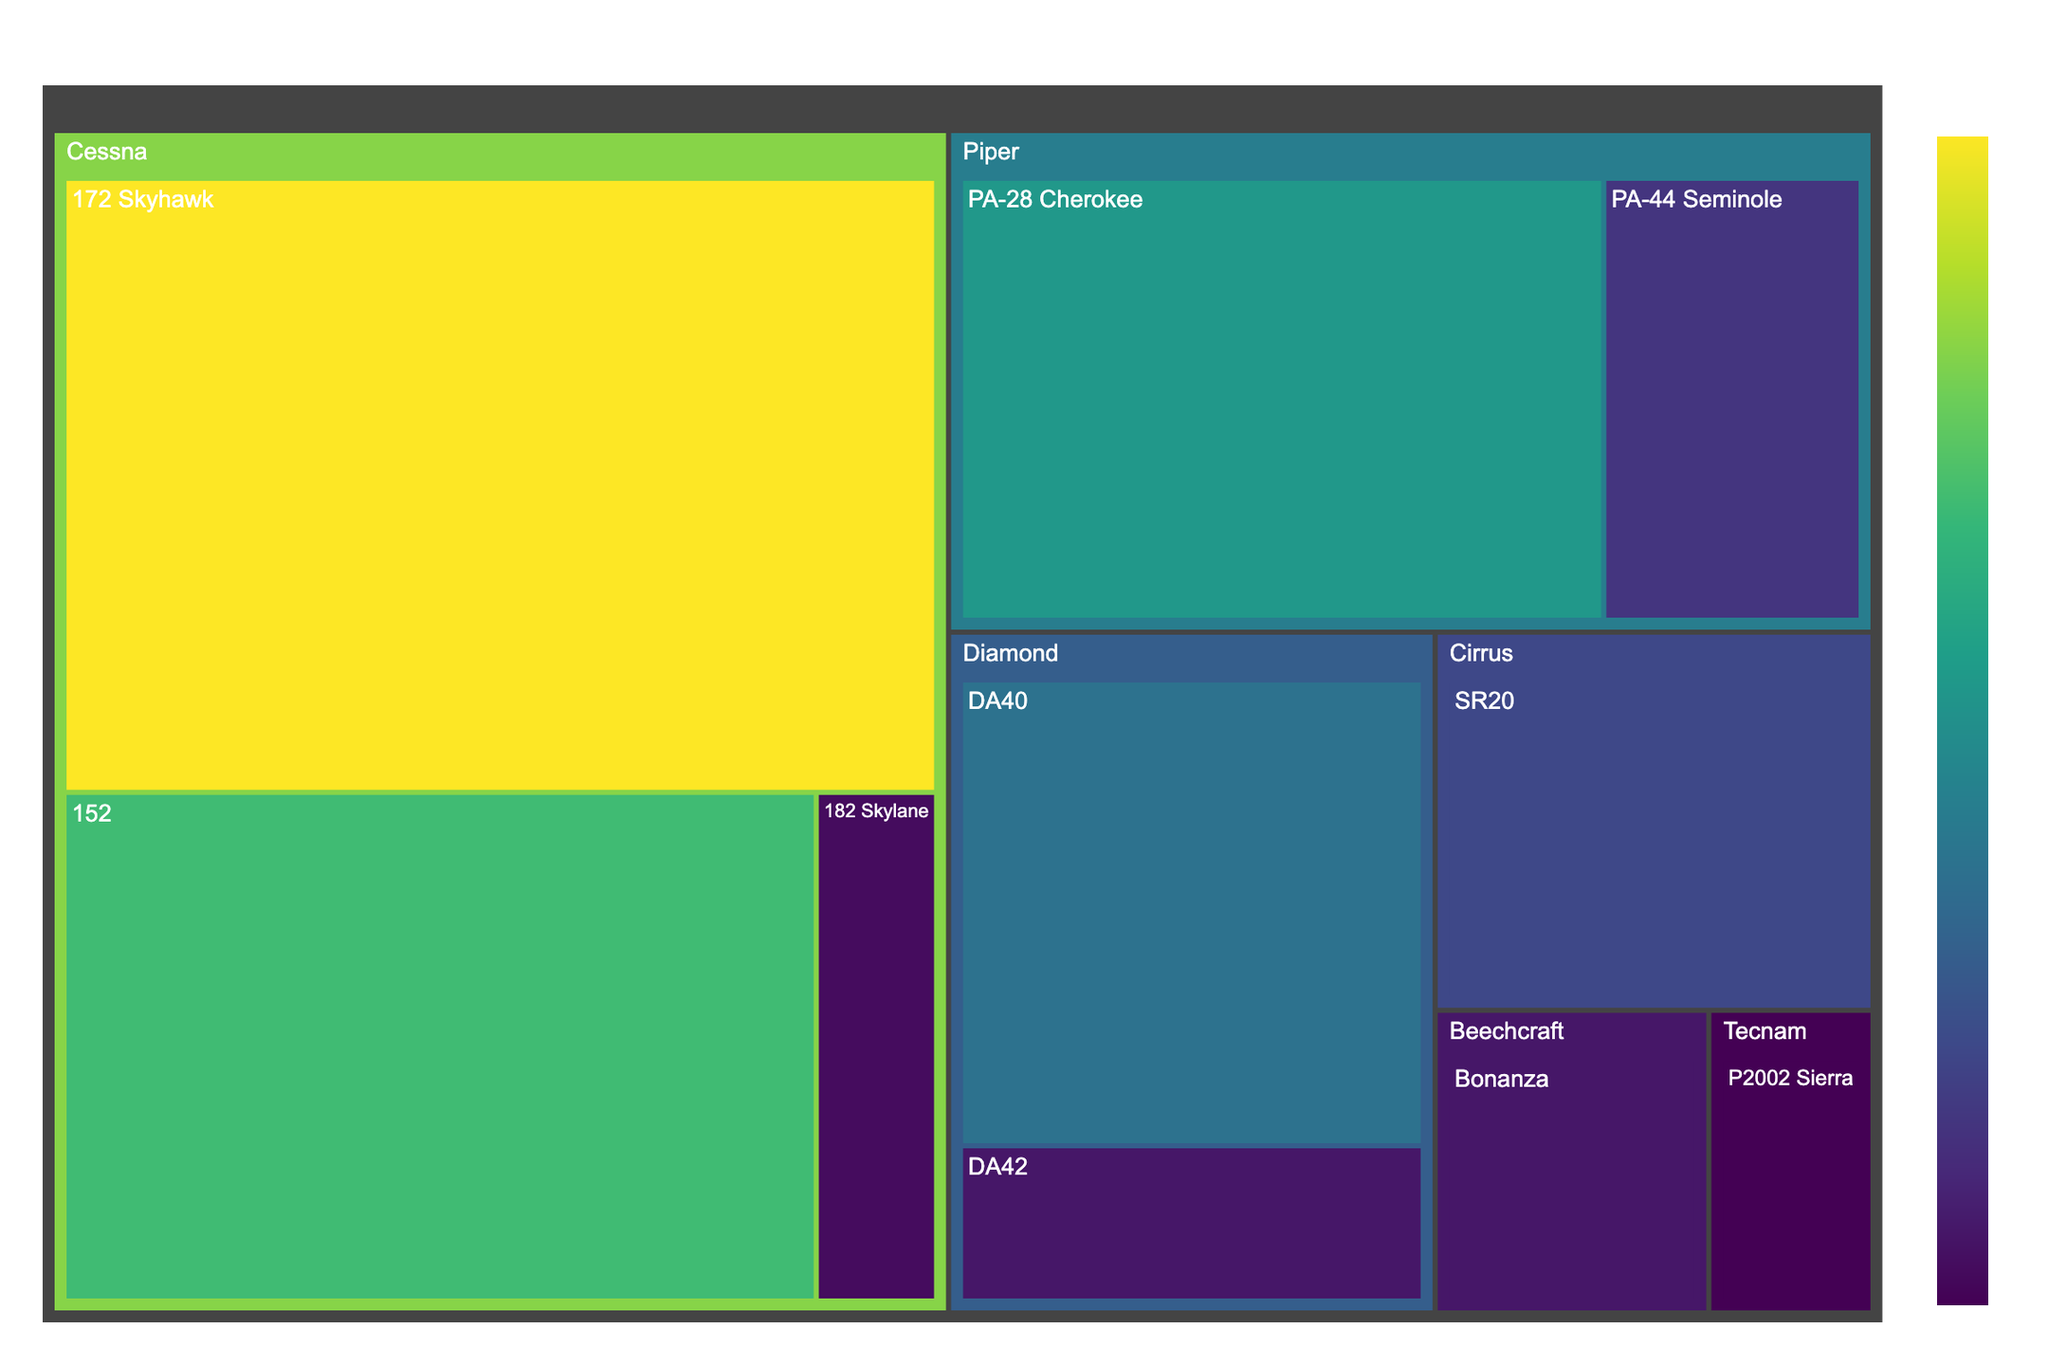What is the title of the treemap figure? The title of the figure is usually displayed at the top, summarizing the content.
Answer: Aircraft Types Used in Flight Training Which aircraft model has the highest usage? Look for the largest segment in the treemap and check its label.
Answer: Cessna 172 Skyhawk How many models are listed under the manufacturer Piper? Identify the segments under the "Piper" section and count them.
Answer: 2 What is the total combined usage of Diamond aircraft models? Locate the segments under "Diamond", sum their usage numbers: 15 (DA40) + 5 (DA42).
Answer: 20 Which aircraft manufacturer has the most models represented in the treemap? Count the number of segments for each manufacturer.
Answer: Cessna Compare the usage of the Cessna 152 and the Cirrus SR20. Which one has higher usage and by how much? Find the segments labeled "Cessna 152" and "Cirrus SR20", compare their usage numbers: 25 (Cessna 152) - 10 (Cirrus SR20).
Answer: Cessna 152 by 15 What is the color used for the highest usage value and the lowest usage value in the treemap? The treemap uses a color scale (Viridis), with colors indicating usage values. Identify the colors for the largest and smallest segments.
Answer: Darkest shade (for highest), lightest shade (for lowest) Add up the usage values for all the models under Cessna. Sum the usage numbers for models under "Cessna": 35 (172 Skyhawk) + 25 (152) + 4 (182 Skylane).
Answer: 64 Which has a higher usage value: Piper PA-28 Cherokee or Diamond DA40? Compare the usage numbers for "Piper PA-28 Cherokee" and "Diamond DA40": 20 (PA-28 Cherokee) vs 15 (DA40).
Answer: Piper PA-28 Cherokee How many manufacturers are represented in the treemap? Count the number of unique manufacturer names on the treemap.
Answer: 6 